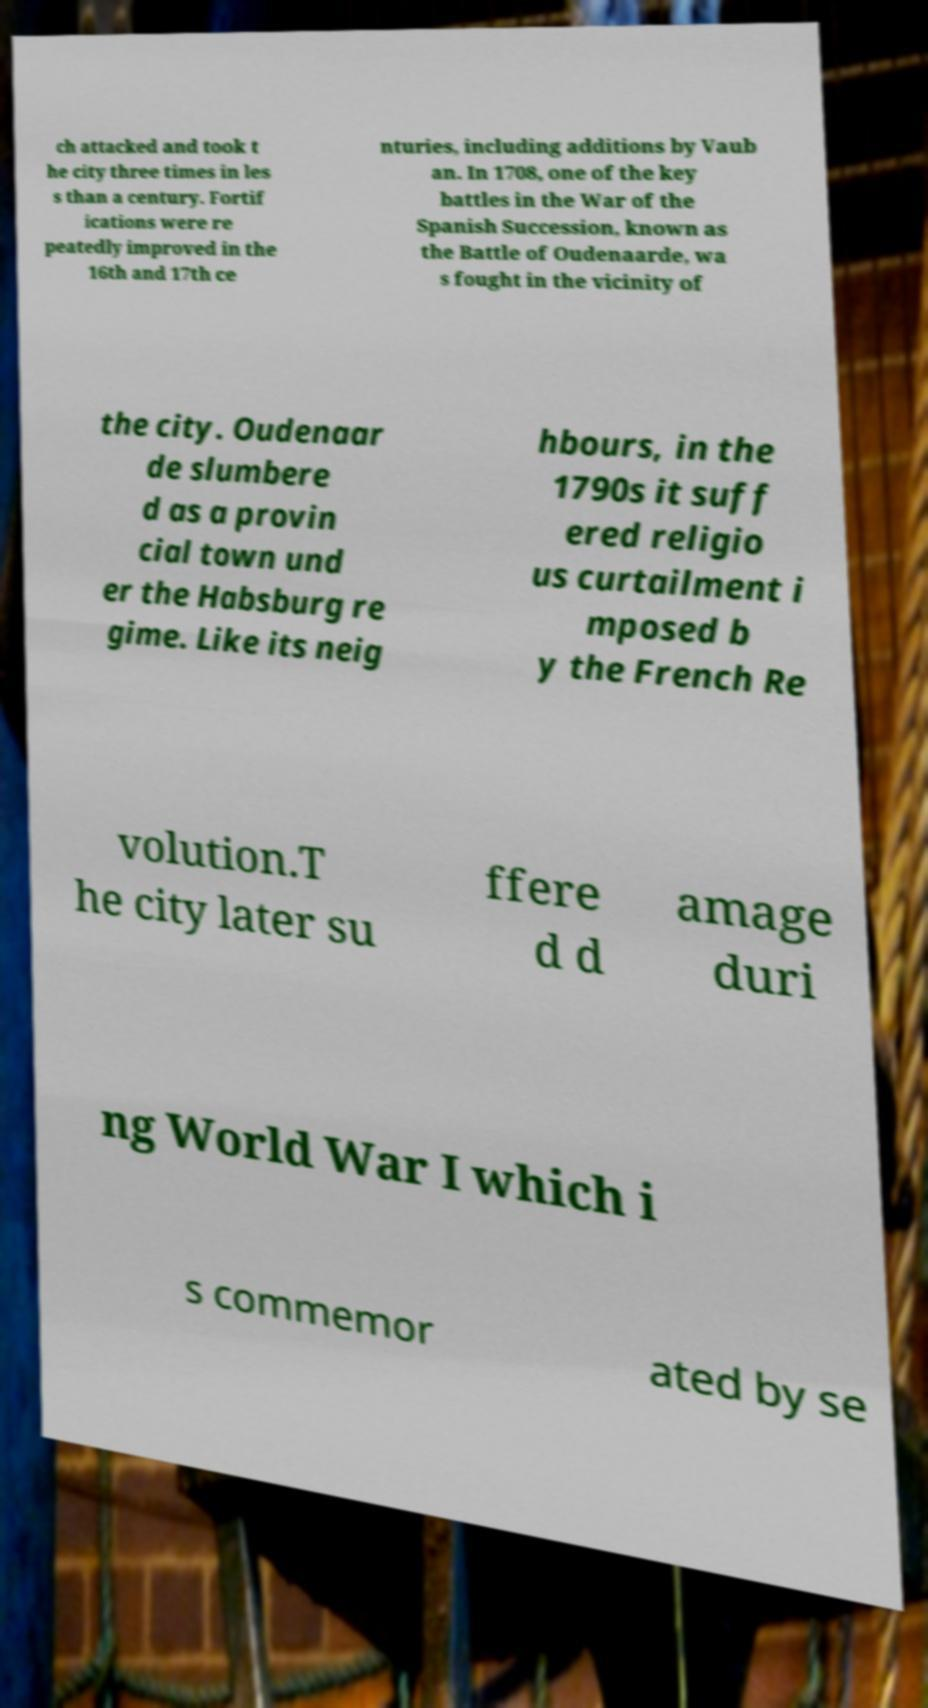Can you accurately transcribe the text from the provided image for me? ch attacked and took t he city three times in les s than a century. Fortif ications were re peatedly improved in the 16th and 17th ce nturies, including additions by Vaub an. In 1708, one of the key battles in the War of the Spanish Succession, known as the Battle of Oudenaarde, wa s fought in the vicinity of the city. Oudenaar de slumbere d as a provin cial town und er the Habsburg re gime. Like its neig hbours, in the 1790s it suff ered religio us curtailment i mposed b y the French Re volution.T he city later su ffere d d amage duri ng World War I which i s commemor ated by se 